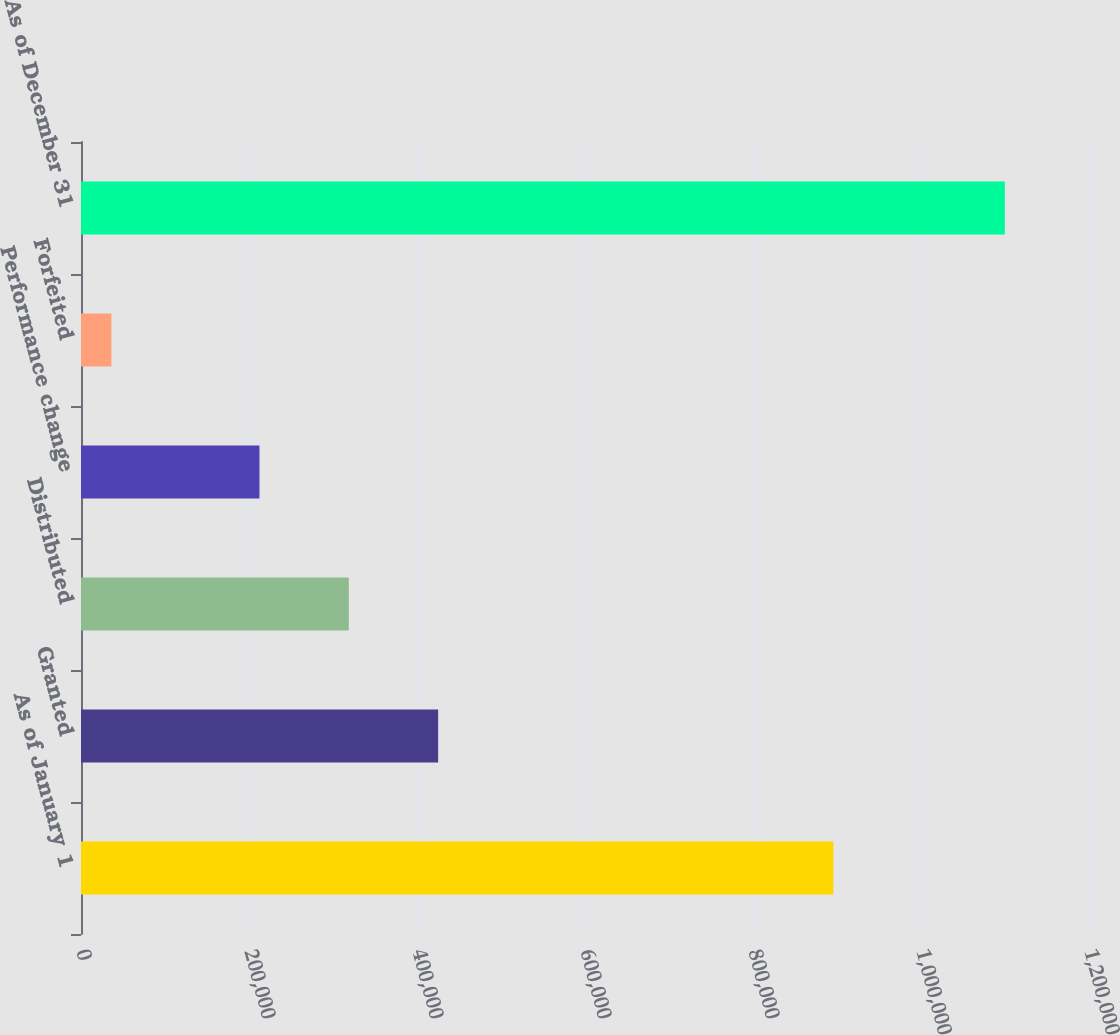<chart> <loc_0><loc_0><loc_500><loc_500><bar_chart><fcel>As of January 1<fcel>Granted<fcel>Distributed<fcel>Performance change<fcel>Forfeited<fcel>As of December 31<nl><fcel>895635<fcel>425169<fcel>318815<fcel>212461<fcel>36212<fcel>1.09975e+06<nl></chart> 